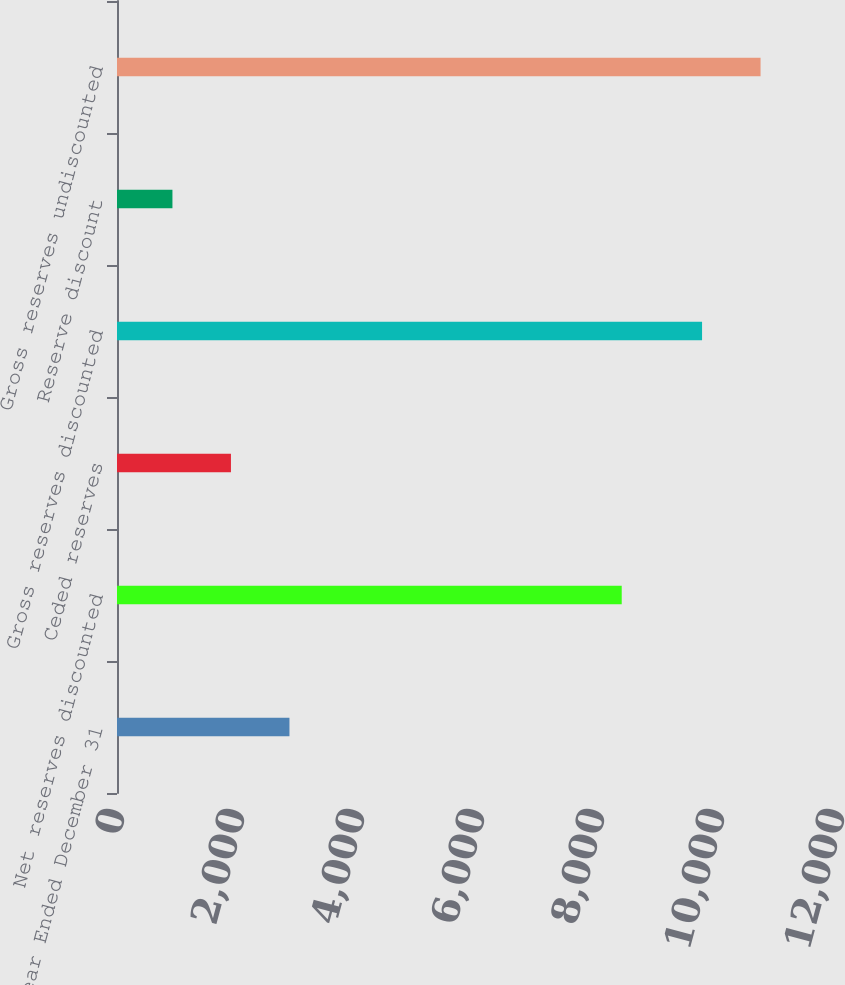Convert chart. <chart><loc_0><loc_0><loc_500><loc_500><bar_chart><fcel>Year Ended December 31<fcel>Net reserves discounted<fcel>Ceded reserves<fcel>Gross reserves discounted<fcel>Reserve discount<fcel>Gross reserves undiscounted<nl><fcel>2874.2<fcel>8412<fcel>1899.1<fcel>9751<fcel>924<fcel>10726.1<nl></chart> 